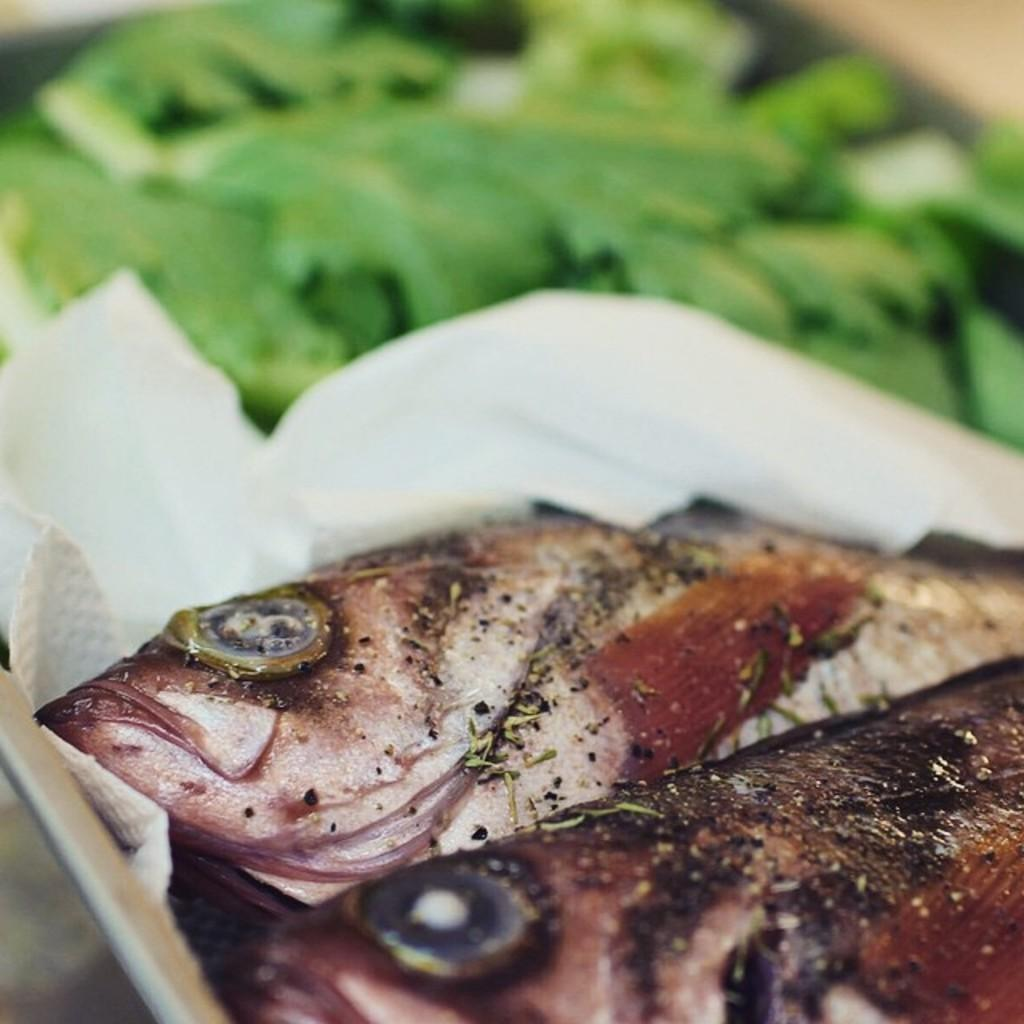What is depicted in the image? There are two fish pieces in the image. How are the fish pieces presented? The fish pieces are wrapped in tissue paper. What can be seen in the background of the image? There are green leaves in the background of the image. What type of cart is used to transport the fish pieces in the image? There is no cart present in the image; the fish pieces are wrapped in tissue paper. Can you tell me how the self is depicted in the image? There is no self or person depicted in the image; it features two fish pieces wrapped in tissue paper and green leaves in the background. 